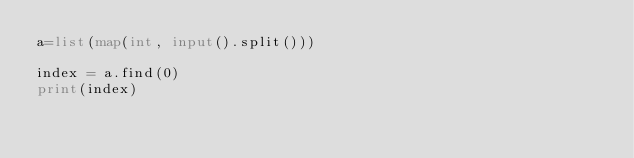<code> <loc_0><loc_0><loc_500><loc_500><_Python_>a=list(map(int, input().split()))

index = a.find(0)
print(index)</code> 